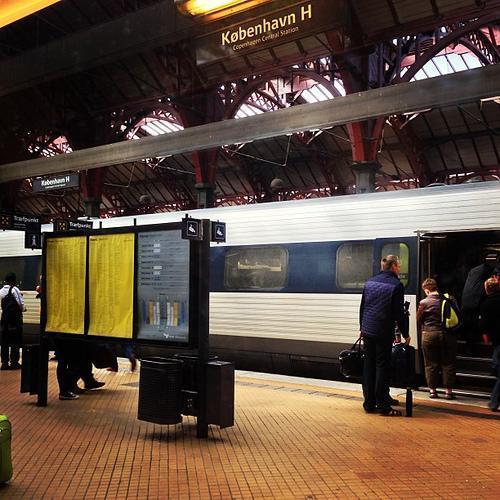How many yellow signs are there?
Give a very brief answer. 2. 